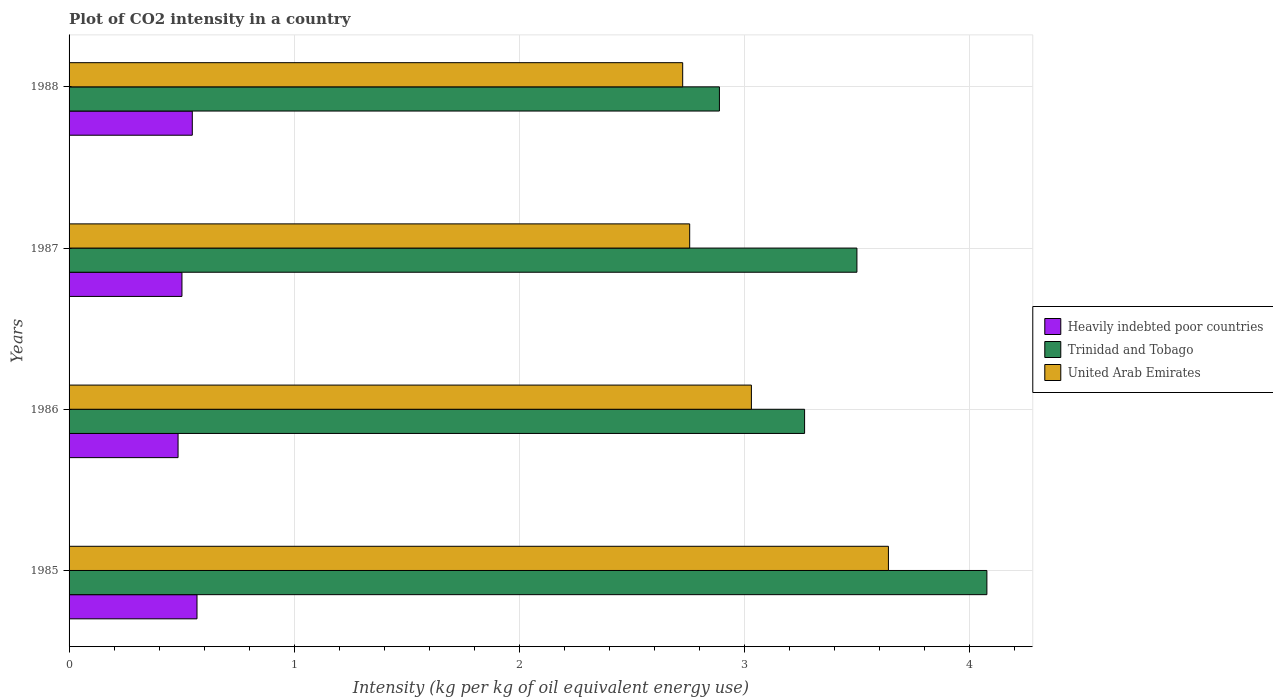How many different coloured bars are there?
Provide a short and direct response. 3. Are the number of bars per tick equal to the number of legend labels?
Your answer should be very brief. Yes. What is the label of the 1st group of bars from the top?
Your response must be concise. 1988. In how many cases, is the number of bars for a given year not equal to the number of legend labels?
Ensure brevity in your answer.  0. What is the CO2 intensity in in United Arab Emirates in 1988?
Give a very brief answer. 2.73. Across all years, what is the maximum CO2 intensity in in Trinidad and Tobago?
Provide a short and direct response. 4.08. Across all years, what is the minimum CO2 intensity in in United Arab Emirates?
Keep it short and to the point. 2.73. In which year was the CO2 intensity in in Trinidad and Tobago maximum?
Offer a very short reply. 1985. In which year was the CO2 intensity in in United Arab Emirates minimum?
Your answer should be compact. 1988. What is the total CO2 intensity in in Heavily indebted poor countries in the graph?
Offer a very short reply. 2.1. What is the difference between the CO2 intensity in in United Arab Emirates in 1986 and that in 1987?
Make the answer very short. 0.27. What is the difference between the CO2 intensity in in Trinidad and Tobago in 1988 and the CO2 intensity in in Heavily indebted poor countries in 1985?
Provide a short and direct response. 2.32. What is the average CO2 intensity in in Heavily indebted poor countries per year?
Offer a very short reply. 0.53. In the year 1987, what is the difference between the CO2 intensity in in United Arab Emirates and CO2 intensity in in Heavily indebted poor countries?
Give a very brief answer. 2.26. What is the ratio of the CO2 intensity in in Trinidad and Tobago in 1986 to that in 1987?
Offer a terse response. 0.93. Is the difference between the CO2 intensity in in United Arab Emirates in 1985 and 1987 greater than the difference between the CO2 intensity in in Heavily indebted poor countries in 1985 and 1987?
Your answer should be very brief. Yes. What is the difference between the highest and the second highest CO2 intensity in in Trinidad and Tobago?
Provide a succinct answer. 0.58. What is the difference between the highest and the lowest CO2 intensity in in Heavily indebted poor countries?
Provide a short and direct response. 0.08. In how many years, is the CO2 intensity in in United Arab Emirates greater than the average CO2 intensity in in United Arab Emirates taken over all years?
Offer a very short reply. 1. Is the sum of the CO2 intensity in in United Arab Emirates in 1986 and 1988 greater than the maximum CO2 intensity in in Heavily indebted poor countries across all years?
Keep it short and to the point. Yes. What does the 3rd bar from the top in 1987 represents?
Provide a short and direct response. Heavily indebted poor countries. What does the 1st bar from the bottom in 1988 represents?
Your response must be concise. Heavily indebted poor countries. Is it the case that in every year, the sum of the CO2 intensity in in Heavily indebted poor countries and CO2 intensity in in Trinidad and Tobago is greater than the CO2 intensity in in United Arab Emirates?
Make the answer very short. Yes. Are all the bars in the graph horizontal?
Give a very brief answer. Yes. What is the difference between two consecutive major ticks on the X-axis?
Provide a short and direct response. 1. Does the graph contain any zero values?
Provide a succinct answer. No. How are the legend labels stacked?
Give a very brief answer. Vertical. What is the title of the graph?
Give a very brief answer. Plot of CO2 intensity in a country. What is the label or title of the X-axis?
Provide a short and direct response. Intensity (kg per kg of oil equivalent energy use). What is the Intensity (kg per kg of oil equivalent energy use) in Heavily indebted poor countries in 1985?
Your answer should be compact. 0.57. What is the Intensity (kg per kg of oil equivalent energy use) of Trinidad and Tobago in 1985?
Your answer should be compact. 4.08. What is the Intensity (kg per kg of oil equivalent energy use) of United Arab Emirates in 1985?
Ensure brevity in your answer.  3.64. What is the Intensity (kg per kg of oil equivalent energy use) of Heavily indebted poor countries in 1986?
Your answer should be compact. 0.48. What is the Intensity (kg per kg of oil equivalent energy use) of Trinidad and Tobago in 1986?
Your answer should be very brief. 3.27. What is the Intensity (kg per kg of oil equivalent energy use) of United Arab Emirates in 1986?
Make the answer very short. 3.03. What is the Intensity (kg per kg of oil equivalent energy use) in Heavily indebted poor countries in 1987?
Ensure brevity in your answer.  0.5. What is the Intensity (kg per kg of oil equivalent energy use) in Trinidad and Tobago in 1987?
Provide a short and direct response. 3.5. What is the Intensity (kg per kg of oil equivalent energy use) in United Arab Emirates in 1987?
Make the answer very short. 2.76. What is the Intensity (kg per kg of oil equivalent energy use) in Heavily indebted poor countries in 1988?
Your answer should be very brief. 0.55. What is the Intensity (kg per kg of oil equivalent energy use) in Trinidad and Tobago in 1988?
Give a very brief answer. 2.89. What is the Intensity (kg per kg of oil equivalent energy use) of United Arab Emirates in 1988?
Your answer should be compact. 2.73. Across all years, what is the maximum Intensity (kg per kg of oil equivalent energy use) in Heavily indebted poor countries?
Your answer should be compact. 0.57. Across all years, what is the maximum Intensity (kg per kg of oil equivalent energy use) of Trinidad and Tobago?
Give a very brief answer. 4.08. Across all years, what is the maximum Intensity (kg per kg of oil equivalent energy use) of United Arab Emirates?
Your answer should be compact. 3.64. Across all years, what is the minimum Intensity (kg per kg of oil equivalent energy use) of Heavily indebted poor countries?
Offer a very short reply. 0.48. Across all years, what is the minimum Intensity (kg per kg of oil equivalent energy use) of Trinidad and Tobago?
Give a very brief answer. 2.89. Across all years, what is the minimum Intensity (kg per kg of oil equivalent energy use) of United Arab Emirates?
Provide a short and direct response. 2.73. What is the total Intensity (kg per kg of oil equivalent energy use) of Heavily indebted poor countries in the graph?
Ensure brevity in your answer.  2.1. What is the total Intensity (kg per kg of oil equivalent energy use) of Trinidad and Tobago in the graph?
Ensure brevity in your answer.  13.73. What is the total Intensity (kg per kg of oil equivalent energy use) of United Arab Emirates in the graph?
Ensure brevity in your answer.  12.15. What is the difference between the Intensity (kg per kg of oil equivalent energy use) of Heavily indebted poor countries in 1985 and that in 1986?
Offer a terse response. 0.08. What is the difference between the Intensity (kg per kg of oil equivalent energy use) of Trinidad and Tobago in 1985 and that in 1986?
Keep it short and to the point. 0.81. What is the difference between the Intensity (kg per kg of oil equivalent energy use) in United Arab Emirates in 1985 and that in 1986?
Offer a terse response. 0.61. What is the difference between the Intensity (kg per kg of oil equivalent energy use) in Heavily indebted poor countries in 1985 and that in 1987?
Your answer should be compact. 0.07. What is the difference between the Intensity (kg per kg of oil equivalent energy use) of Trinidad and Tobago in 1985 and that in 1987?
Make the answer very short. 0.58. What is the difference between the Intensity (kg per kg of oil equivalent energy use) in United Arab Emirates in 1985 and that in 1987?
Make the answer very short. 0.88. What is the difference between the Intensity (kg per kg of oil equivalent energy use) of Heavily indebted poor countries in 1985 and that in 1988?
Provide a short and direct response. 0.02. What is the difference between the Intensity (kg per kg of oil equivalent energy use) of Trinidad and Tobago in 1985 and that in 1988?
Keep it short and to the point. 1.19. What is the difference between the Intensity (kg per kg of oil equivalent energy use) in United Arab Emirates in 1985 and that in 1988?
Your answer should be very brief. 0.91. What is the difference between the Intensity (kg per kg of oil equivalent energy use) of Heavily indebted poor countries in 1986 and that in 1987?
Keep it short and to the point. -0.02. What is the difference between the Intensity (kg per kg of oil equivalent energy use) in Trinidad and Tobago in 1986 and that in 1987?
Your response must be concise. -0.23. What is the difference between the Intensity (kg per kg of oil equivalent energy use) of United Arab Emirates in 1986 and that in 1987?
Your answer should be very brief. 0.27. What is the difference between the Intensity (kg per kg of oil equivalent energy use) in Heavily indebted poor countries in 1986 and that in 1988?
Offer a terse response. -0.06. What is the difference between the Intensity (kg per kg of oil equivalent energy use) in Trinidad and Tobago in 1986 and that in 1988?
Your answer should be compact. 0.38. What is the difference between the Intensity (kg per kg of oil equivalent energy use) in United Arab Emirates in 1986 and that in 1988?
Your answer should be very brief. 0.31. What is the difference between the Intensity (kg per kg of oil equivalent energy use) of Heavily indebted poor countries in 1987 and that in 1988?
Your answer should be compact. -0.05. What is the difference between the Intensity (kg per kg of oil equivalent energy use) in Trinidad and Tobago in 1987 and that in 1988?
Give a very brief answer. 0.61. What is the difference between the Intensity (kg per kg of oil equivalent energy use) of United Arab Emirates in 1987 and that in 1988?
Offer a very short reply. 0.03. What is the difference between the Intensity (kg per kg of oil equivalent energy use) in Heavily indebted poor countries in 1985 and the Intensity (kg per kg of oil equivalent energy use) in Trinidad and Tobago in 1986?
Keep it short and to the point. -2.7. What is the difference between the Intensity (kg per kg of oil equivalent energy use) of Heavily indebted poor countries in 1985 and the Intensity (kg per kg of oil equivalent energy use) of United Arab Emirates in 1986?
Offer a terse response. -2.46. What is the difference between the Intensity (kg per kg of oil equivalent energy use) of Trinidad and Tobago in 1985 and the Intensity (kg per kg of oil equivalent energy use) of United Arab Emirates in 1986?
Make the answer very short. 1.05. What is the difference between the Intensity (kg per kg of oil equivalent energy use) in Heavily indebted poor countries in 1985 and the Intensity (kg per kg of oil equivalent energy use) in Trinidad and Tobago in 1987?
Give a very brief answer. -2.93. What is the difference between the Intensity (kg per kg of oil equivalent energy use) in Heavily indebted poor countries in 1985 and the Intensity (kg per kg of oil equivalent energy use) in United Arab Emirates in 1987?
Offer a very short reply. -2.19. What is the difference between the Intensity (kg per kg of oil equivalent energy use) in Trinidad and Tobago in 1985 and the Intensity (kg per kg of oil equivalent energy use) in United Arab Emirates in 1987?
Your answer should be very brief. 1.32. What is the difference between the Intensity (kg per kg of oil equivalent energy use) of Heavily indebted poor countries in 1985 and the Intensity (kg per kg of oil equivalent energy use) of Trinidad and Tobago in 1988?
Provide a short and direct response. -2.32. What is the difference between the Intensity (kg per kg of oil equivalent energy use) in Heavily indebted poor countries in 1985 and the Intensity (kg per kg of oil equivalent energy use) in United Arab Emirates in 1988?
Keep it short and to the point. -2.16. What is the difference between the Intensity (kg per kg of oil equivalent energy use) of Trinidad and Tobago in 1985 and the Intensity (kg per kg of oil equivalent energy use) of United Arab Emirates in 1988?
Make the answer very short. 1.35. What is the difference between the Intensity (kg per kg of oil equivalent energy use) of Heavily indebted poor countries in 1986 and the Intensity (kg per kg of oil equivalent energy use) of Trinidad and Tobago in 1987?
Your response must be concise. -3.02. What is the difference between the Intensity (kg per kg of oil equivalent energy use) of Heavily indebted poor countries in 1986 and the Intensity (kg per kg of oil equivalent energy use) of United Arab Emirates in 1987?
Offer a very short reply. -2.27. What is the difference between the Intensity (kg per kg of oil equivalent energy use) of Trinidad and Tobago in 1986 and the Intensity (kg per kg of oil equivalent energy use) of United Arab Emirates in 1987?
Give a very brief answer. 0.51. What is the difference between the Intensity (kg per kg of oil equivalent energy use) of Heavily indebted poor countries in 1986 and the Intensity (kg per kg of oil equivalent energy use) of Trinidad and Tobago in 1988?
Your answer should be very brief. -2.4. What is the difference between the Intensity (kg per kg of oil equivalent energy use) in Heavily indebted poor countries in 1986 and the Intensity (kg per kg of oil equivalent energy use) in United Arab Emirates in 1988?
Give a very brief answer. -2.24. What is the difference between the Intensity (kg per kg of oil equivalent energy use) in Trinidad and Tobago in 1986 and the Intensity (kg per kg of oil equivalent energy use) in United Arab Emirates in 1988?
Keep it short and to the point. 0.54. What is the difference between the Intensity (kg per kg of oil equivalent energy use) of Heavily indebted poor countries in 1987 and the Intensity (kg per kg of oil equivalent energy use) of Trinidad and Tobago in 1988?
Give a very brief answer. -2.39. What is the difference between the Intensity (kg per kg of oil equivalent energy use) in Heavily indebted poor countries in 1987 and the Intensity (kg per kg of oil equivalent energy use) in United Arab Emirates in 1988?
Provide a short and direct response. -2.22. What is the difference between the Intensity (kg per kg of oil equivalent energy use) of Trinidad and Tobago in 1987 and the Intensity (kg per kg of oil equivalent energy use) of United Arab Emirates in 1988?
Your answer should be compact. 0.77. What is the average Intensity (kg per kg of oil equivalent energy use) of Heavily indebted poor countries per year?
Provide a succinct answer. 0.53. What is the average Intensity (kg per kg of oil equivalent energy use) of Trinidad and Tobago per year?
Keep it short and to the point. 3.43. What is the average Intensity (kg per kg of oil equivalent energy use) in United Arab Emirates per year?
Ensure brevity in your answer.  3.04. In the year 1985, what is the difference between the Intensity (kg per kg of oil equivalent energy use) of Heavily indebted poor countries and Intensity (kg per kg of oil equivalent energy use) of Trinidad and Tobago?
Make the answer very short. -3.51. In the year 1985, what is the difference between the Intensity (kg per kg of oil equivalent energy use) of Heavily indebted poor countries and Intensity (kg per kg of oil equivalent energy use) of United Arab Emirates?
Keep it short and to the point. -3.07. In the year 1985, what is the difference between the Intensity (kg per kg of oil equivalent energy use) of Trinidad and Tobago and Intensity (kg per kg of oil equivalent energy use) of United Arab Emirates?
Make the answer very short. 0.44. In the year 1986, what is the difference between the Intensity (kg per kg of oil equivalent energy use) of Heavily indebted poor countries and Intensity (kg per kg of oil equivalent energy use) of Trinidad and Tobago?
Ensure brevity in your answer.  -2.78. In the year 1986, what is the difference between the Intensity (kg per kg of oil equivalent energy use) of Heavily indebted poor countries and Intensity (kg per kg of oil equivalent energy use) of United Arab Emirates?
Give a very brief answer. -2.55. In the year 1986, what is the difference between the Intensity (kg per kg of oil equivalent energy use) in Trinidad and Tobago and Intensity (kg per kg of oil equivalent energy use) in United Arab Emirates?
Give a very brief answer. 0.24. In the year 1987, what is the difference between the Intensity (kg per kg of oil equivalent energy use) of Heavily indebted poor countries and Intensity (kg per kg of oil equivalent energy use) of Trinidad and Tobago?
Make the answer very short. -3. In the year 1987, what is the difference between the Intensity (kg per kg of oil equivalent energy use) in Heavily indebted poor countries and Intensity (kg per kg of oil equivalent energy use) in United Arab Emirates?
Make the answer very short. -2.26. In the year 1987, what is the difference between the Intensity (kg per kg of oil equivalent energy use) of Trinidad and Tobago and Intensity (kg per kg of oil equivalent energy use) of United Arab Emirates?
Make the answer very short. 0.74. In the year 1988, what is the difference between the Intensity (kg per kg of oil equivalent energy use) of Heavily indebted poor countries and Intensity (kg per kg of oil equivalent energy use) of Trinidad and Tobago?
Offer a terse response. -2.34. In the year 1988, what is the difference between the Intensity (kg per kg of oil equivalent energy use) in Heavily indebted poor countries and Intensity (kg per kg of oil equivalent energy use) in United Arab Emirates?
Your answer should be very brief. -2.18. In the year 1988, what is the difference between the Intensity (kg per kg of oil equivalent energy use) in Trinidad and Tobago and Intensity (kg per kg of oil equivalent energy use) in United Arab Emirates?
Your answer should be compact. 0.16. What is the ratio of the Intensity (kg per kg of oil equivalent energy use) of Heavily indebted poor countries in 1985 to that in 1986?
Your response must be concise. 1.17. What is the ratio of the Intensity (kg per kg of oil equivalent energy use) of Trinidad and Tobago in 1985 to that in 1986?
Make the answer very short. 1.25. What is the ratio of the Intensity (kg per kg of oil equivalent energy use) of United Arab Emirates in 1985 to that in 1986?
Make the answer very short. 1.2. What is the ratio of the Intensity (kg per kg of oil equivalent energy use) in Heavily indebted poor countries in 1985 to that in 1987?
Provide a succinct answer. 1.13. What is the ratio of the Intensity (kg per kg of oil equivalent energy use) of Trinidad and Tobago in 1985 to that in 1987?
Provide a succinct answer. 1.17. What is the ratio of the Intensity (kg per kg of oil equivalent energy use) of United Arab Emirates in 1985 to that in 1987?
Your response must be concise. 1.32. What is the ratio of the Intensity (kg per kg of oil equivalent energy use) in Heavily indebted poor countries in 1985 to that in 1988?
Keep it short and to the point. 1.04. What is the ratio of the Intensity (kg per kg of oil equivalent energy use) in Trinidad and Tobago in 1985 to that in 1988?
Your answer should be compact. 1.41. What is the ratio of the Intensity (kg per kg of oil equivalent energy use) of United Arab Emirates in 1985 to that in 1988?
Your answer should be very brief. 1.34. What is the ratio of the Intensity (kg per kg of oil equivalent energy use) in Heavily indebted poor countries in 1986 to that in 1987?
Your answer should be very brief. 0.97. What is the ratio of the Intensity (kg per kg of oil equivalent energy use) of Trinidad and Tobago in 1986 to that in 1987?
Your answer should be very brief. 0.93. What is the ratio of the Intensity (kg per kg of oil equivalent energy use) of United Arab Emirates in 1986 to that in 1987?
Offer a very short reply. 1.1. What is the ratio of the Intensity (kg per kg of oil equivalent energy use) of Heavily indebted poor countries in 1986 to that in 1988?
Ensure brevity in your answer.  0.88. What is the ratio of the Intensity (kg per kg of oil equivalent energy use) of Trinidad and Tobago in 1986 to that in 1988?
Make the answer very short. 1.13. What is the ratio of the Intensity (kg per kg of oil equivalent energy use) of United Arab Emirates in 1986 to that in 1988?
Your answer should be very brief. 1.11. What is the ratio of the Intensity (kg per kg of oil equivalent energy use) of Heavily indebted poor countries in 1987 to that in 1988?
Give a very brief answer. 0.92. What is the ratio of the Intensity (kg per kg of oil equivalent energy use) of Trinidad and Tobago in 1987 to that in 1988?
Give a very brief answer. 1.21. What is the ratio of the Intensity (kg per kg of oil equivalent energy use) of United Arab Emirates in 1987 to that in 1988?
Your answer should be very brief. 1.01. What is the difference between the highest and the second highest Intensity (kg per kg of oil equivalent energy use) in Heavily indebted poor countries?
Provide a succinct answer. 0.02. What is the difference between the highest and the second highest Intensity (kg per kg of oil equivalent energy use) of Trinidad and Tobago?
Your answer should be compact. 0.58. What is the difference between the highest and the second highest Intensity (kg per kg of oil equivalent energy use) of United Arab Emirates?
Offer a very short reply. 0.61. What is the difference between the highest and the lowest Intensity (kg per kg of oil equivalent energy use) of Heavily indebted poor countries?
Your response must be concise. 0.08. What is the difference between the highest and the lowest Intensity (kg per kg of oil equivalent energy use) of Trinidad and Tobago?
Your answer should be very brief. 1.19. What is the difference between the highest and the lowest Intensity (kg per kg of oil equivalent energy use) of United Arab Emirates?
Your answer should be compact. 0.91. 